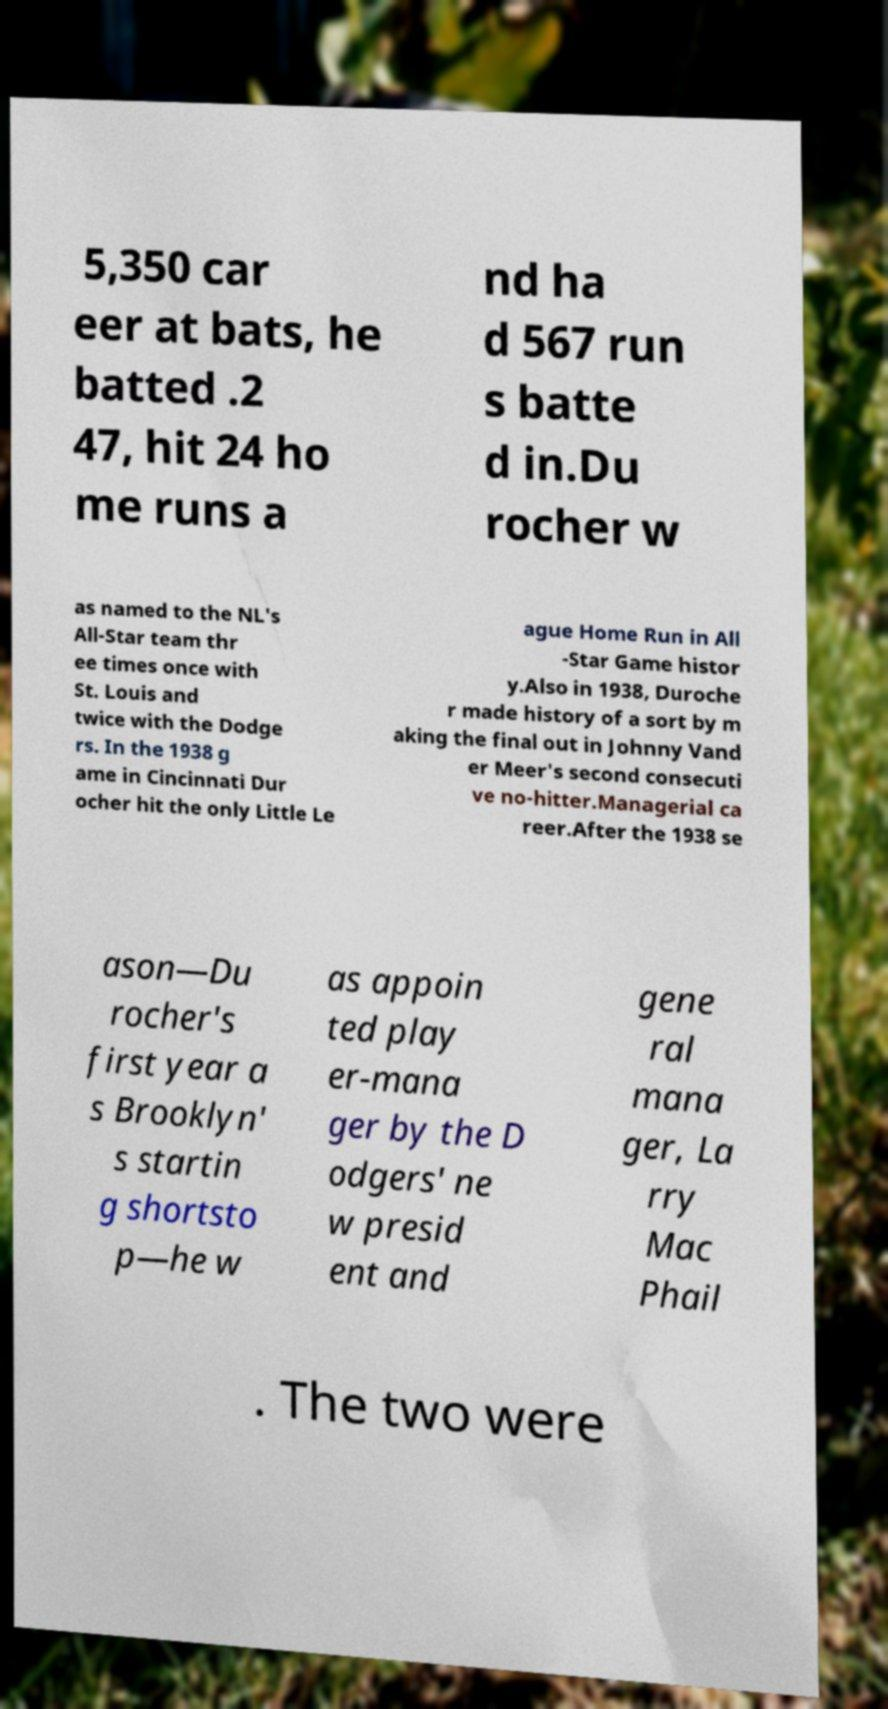Can you accurately transcribe the text from the provided image for me? 5,350 car eer at bats, he batted .2 47, hit 24 ho me runs a nd ha d 567 run s batte d in.Du rocher w as named to the NL's All-Star team thr ee times once with St. Louis and twice with the Dodge rs. In the 1938 g ame in Cincinnati Dur ocher hit the only Little Le ague Home Run in All -Star Game histor y.Also in 1938, Duroche r made history of a sort by m aking the final out in Johnny Vand er Meer's second consecuti ve no-hitter.Managerial ca reer.After the 1938 se ason—Du rocher's first year a s Brooklyn' s startin g shortsto p—he w as appoin ted play er-mana ger by the D odgers' ne w presid ent and gene ral mana ger, La rry Mac Phail . The two were 